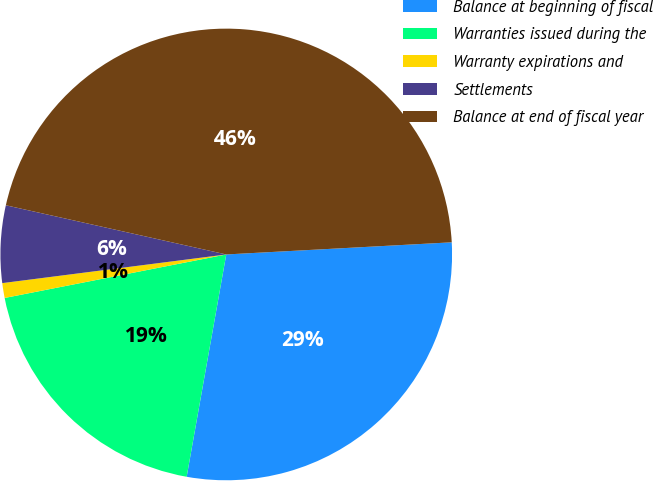Convert chart. <chart><loc_0><loc_0><loc_500><loc_500><pie_chart><fcel>Balance at beginning of fiscal<fcel>Warranties issued during the<fcel>Warranty expirations and<fcel>Settlements<fcel>Balance at end of fiscal year<nl><fcel>28.66%<fcel>19.11%<fcel>1.06%<fcel>5.52%<fcel>45.65%<nl></chart> 